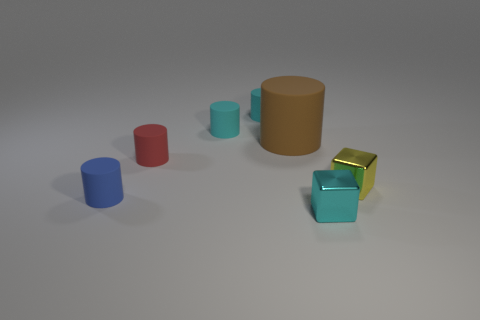Subtract all tiny rubber cylinders. How many cylinders are left? 1 Add 1 small objects. How many objects exist? 8 Subtract all cyan cylinders. How many cylinders are left? 3 Subtract all large cyan shiny cubes. Subtract all large rubber objects. How many objects are left? 6 Add 1 shiny things. How many shiny things are left? 3 Add 7 big yellow matte balls. How many big yellow matte balls exist? 7 Subtract 2 cyan cylinders. How many objects are left? 5 Subtract all cylinders. How many objects are left? 2 Subtract 1 blocks. How many blocks are left? 1 Subtract all yellow cubes. Subtract all gray balls. How many cubes are left? 1 